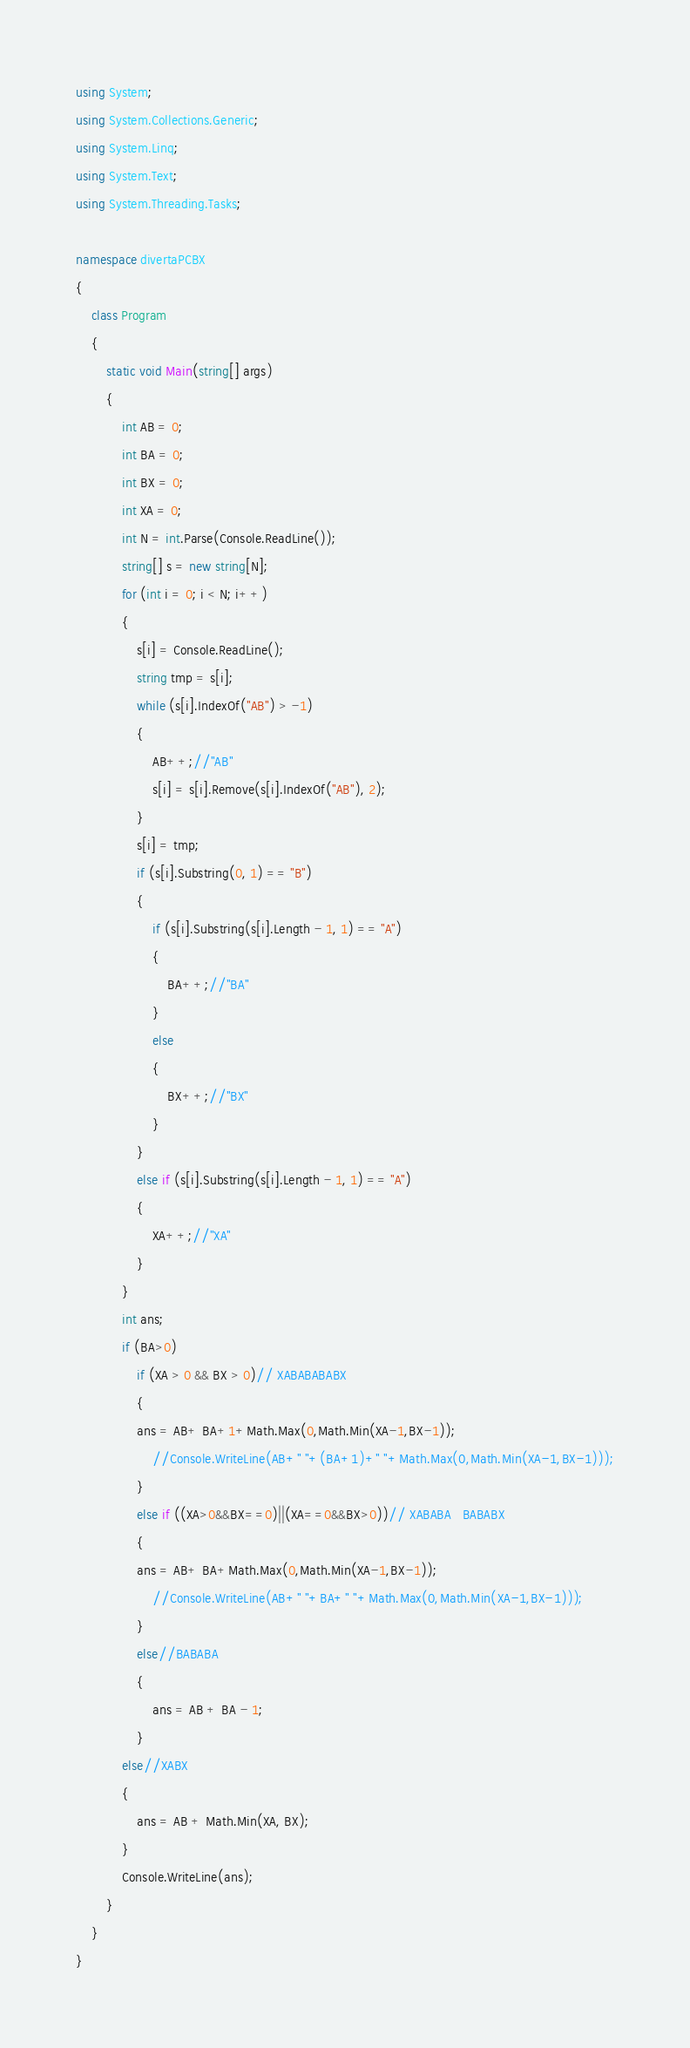<code> <loc_0><loc_0><loc_500><loc_500><_C#_>using System;
using System.Collections.Generic;
using System.Linq;
using System.Text;
using System.Threading.Tasks;

namespace divertaPCBX
{
    class Program
    {
        static void Main(string[] args)
        {
            int AB = 0;
            int BA = 0;
            int BX = 0;
            int XA = 0;
            int N = int.Parse(Console.ReadLine());
            string[] s = new string[N];
            for (int i = 0; i < N; i++)
            {
                s[i] = Console.ReadLine();
                string tmp = s[i];
                while (s[i].IndexOf("AB") > -1)
                {
                    AB++;//"AB"
                    s[i] = s[i].Remove(s[i].IndexOf("AB"), 2);
                }
                s[i] = tmp;
                if (s[i].Substring(0, 1) == "B")
                {
                    if (s[i].Substring(s[i].Length - 1, 1) == "A")
                    {
                        BA++;//"BA"
                    }
                    else
                    {
                        BX++;//"BX"
                    }
                }
                else if (s[i].Substring(s[i].Length - 1, 1) == "A")
                {
                    XA++;//"XA"
                }
            }
            int ans;
            if (BA>0)
                if (XA > 0 && BX > 0)// XABABABABX
                {
                ans = AB+ BA+1+Math.Max(0,Math.Min(XA-1,BX-1));
                    //Console.WriteLine(AB+" "+(BA+1)+" "+Math.Max(0,Math.Min(XA-1,BX-1)));
                }
                else if ((XA>0&&BX==0)||(XA==0&&BX>0))// XABABA   BABABX
                {
                ans = AB+ BA+Math.Max(0,Math.Min(XA-1,BX-1));
                    //Console.WriteLine(AB+" "+BA+" "+Math.Max(0,Math.Min(XA-1,BX-1)));
                }
                else//BABABA
                {
                    ans = AB + BA - 1;
                }
            else//XABX
            {
                ans = AB + Math.Min(XA, BX);
            }           
            Console.WriteLine(ans);
        }
    }
}
</code> 